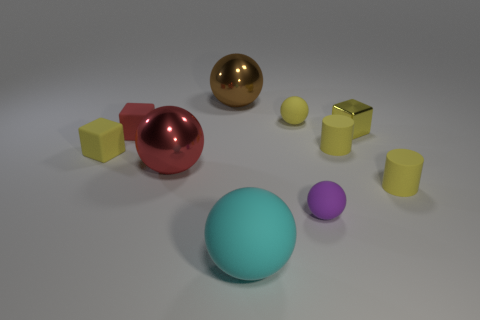Subtract all cyan balls. How many balls are left? 4 Subtract all cyan balls. How many balls are left? 4 Subtract 1 spheres. How many spheres are left? 4 Subtract all gray spheres. Subtract all purple cylinders. How many spheres are left? 5 Subtract all cylinders. How many objects are left? 8 Add 8 large cyan matte spheres. How many large cyan matte spheres exist? 9 Subtract 1 yellow spheres. How many objects are left? 9 Subtract all small yellow metallic blocks. Subtract all large blue rubber things. How many objects are left? 9 Add 3 big metallic objects. How many big metallic objects are left? 5 